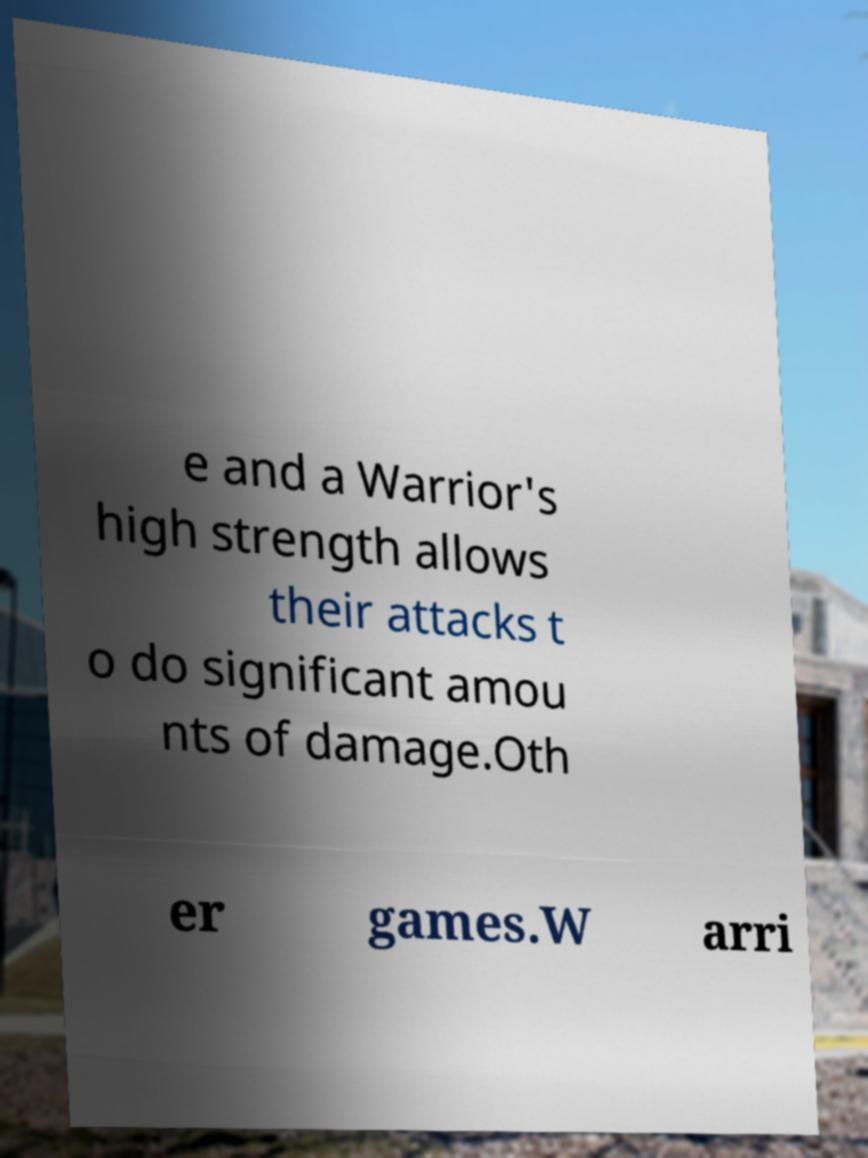Can you read and provide the text displayed in the image?This photo seems to have some interesting text. Can you extract and type it out for me? e and a Warrior's high strength allows their attacks t o do significant amou nts of damage.Oth er games.W arri 